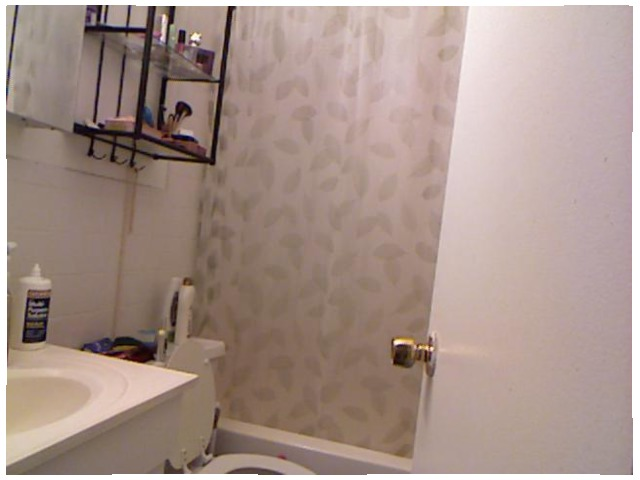<image>
Is there a design on the curtain? Yes. Looking at the image, I can see the design is positioned on top of the curtain, with the curtain providing support. Is the bottle on the sink? Yes. Looking at the image, I can see the bottle is positioned on top of the sink, with the sink providing support. 